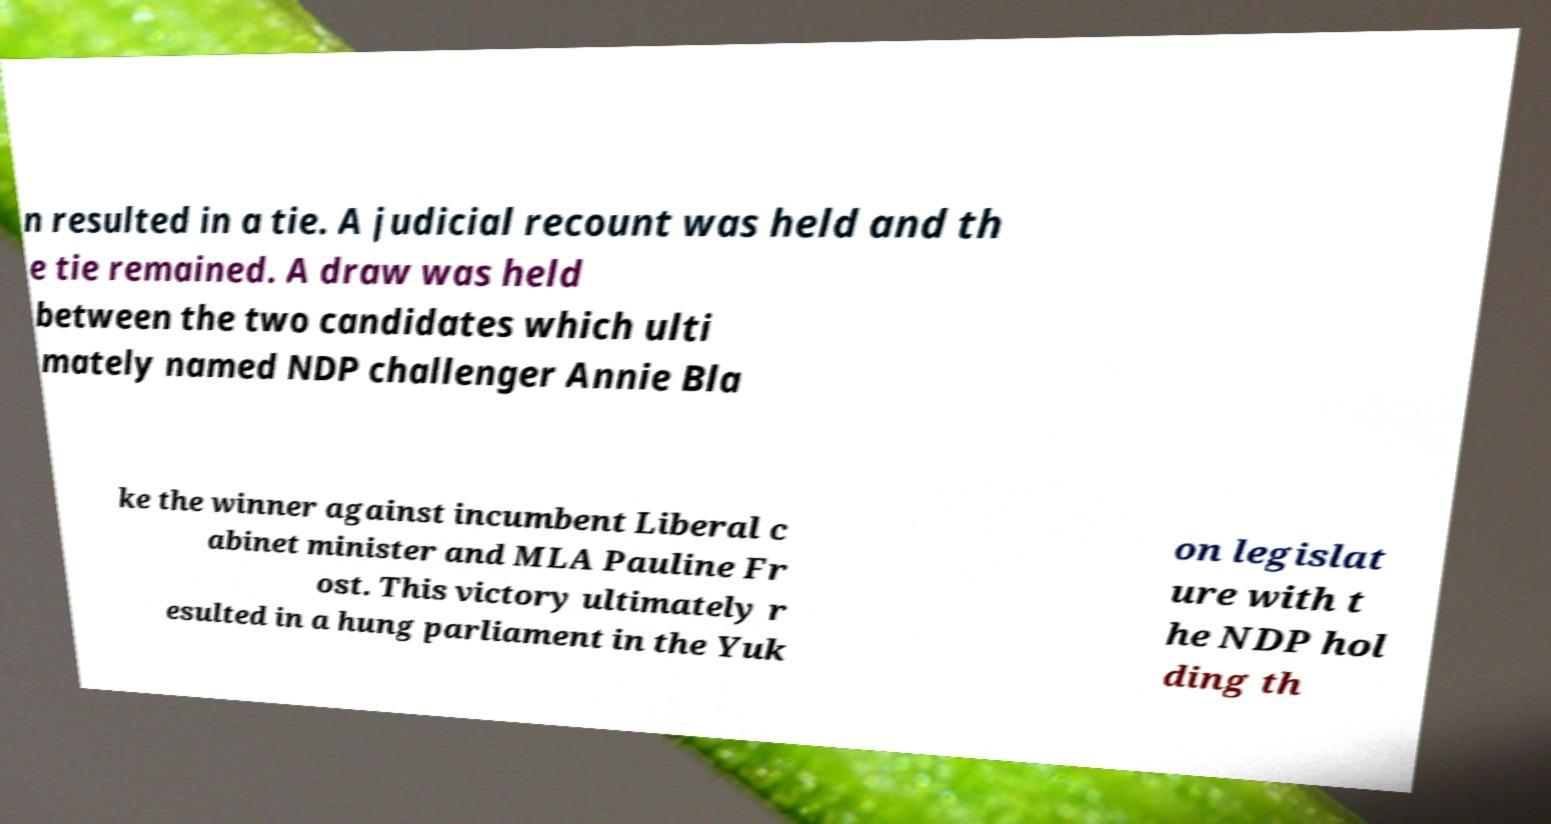What messages or text are displayed in this image? I need them in a readable, typed format. n resulted in a tie. A judicial recount was held and th e tie remained. A draw was held between the two candidates which ulti mately named NDP challenger Annie Bla ke the winner against incumbent Liberal c abinet minister and MLA Pauline Fr ost. This victory ultimately r esulted in a hung parliament in the Yuk on legislat ure with t he NDP hol ding th 